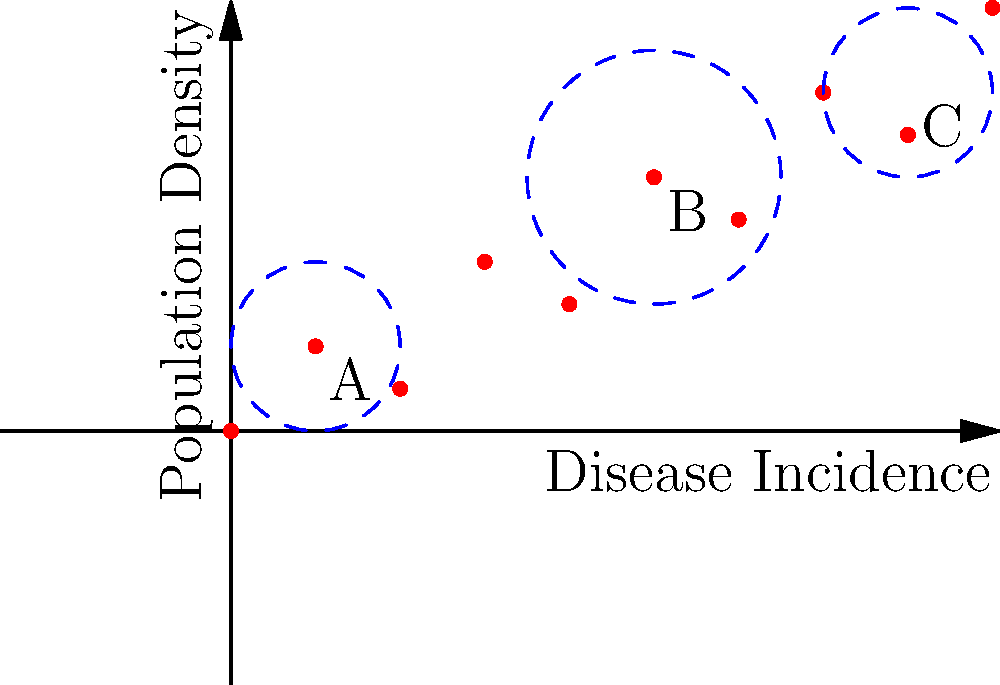In the cluster analysis diagram above, which cluster represents the highest risk area for a disease outbreak, considering both disease incidence and population density? To determine the highest risk area for a disease outbreak, we need to consider both the disease incidence (x-axis) and population density (y-axis). The cluster with the highest combination of these factors will likely pose the greatest risk. Let's analyze each cluster:

1. Cluster A:
   - Located at approximately (1, 1)
   - Low disease incidence and low population density

2. Cluster B:
   - Located at approximately (5, 3)
   - Moderate disease incidence and moderate-to-high population density

3. Cluster C:
   - Located at approximately (8, 4)
   - High disease incidence and high population density

Comparing these clusters:

- Cluster A has the lowest risk due to its low values in both factors.
- Cluster B has moderate risk with intermediate values for both factors.
- Cluster C has the highest risk because it combines high disease incidence with high population density.

The combination of high disease incidence and high population density in Cluster C suggests that:
1. The disease is already prevalent in the area.
2. There is a dense population, which can facilitate rapid disease spread.

This makes Cluster C the most likely area for a significant disease outbreak and, therefore, the highest risk area.
Answer: Cluster C 